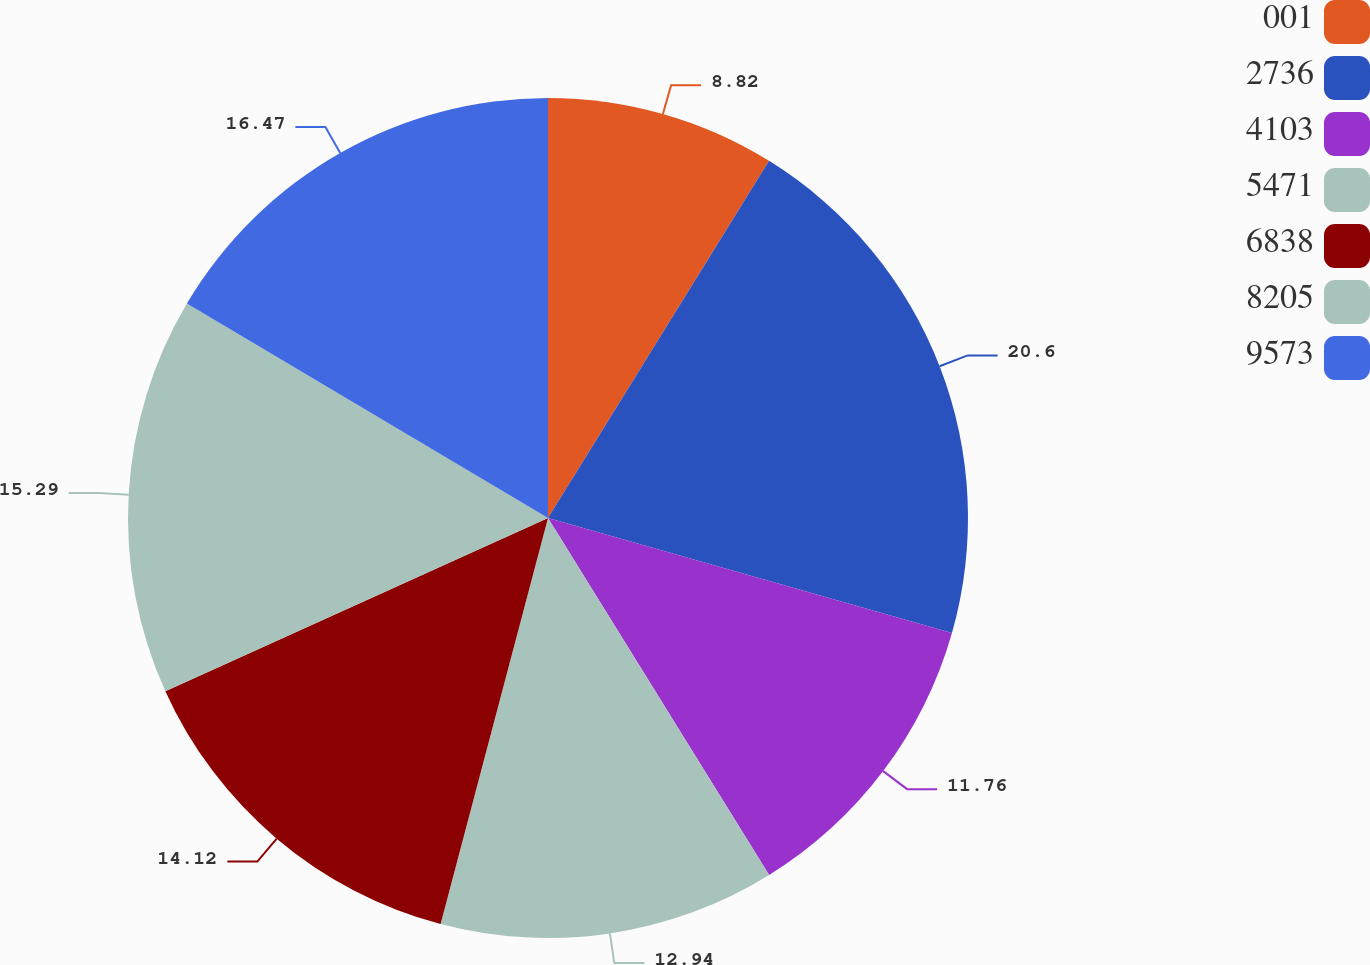Convert chart. <chart><loc_0><loc_0><loc_500><loc_500><pie_chart><fcel>001<fcel>2736<fcel>4103<fcel>5471<fcel>6838<fcel>8205<fcel>9573<nl><fcel>8.82%<fcel>20.59%<fcel>11.76%<fcel>12.94%<fcel>14.12%<fcel>15.29%<fcel>16.47%<nl></chart> 